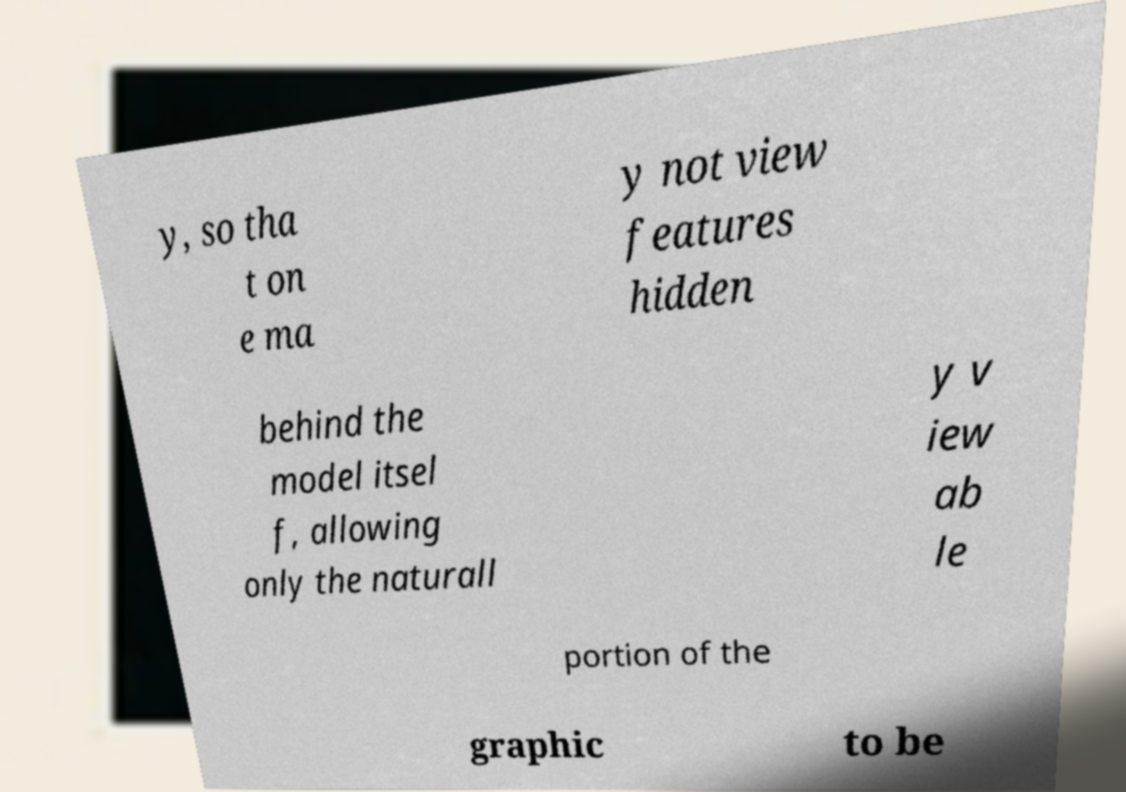Could you assist in decoding the text presented in this image and type it out clearly? y, so tha t on e ma y not view features hidden behind the model itsel f, allowing only the naturall y v iew ab le portion of the graphic to be 